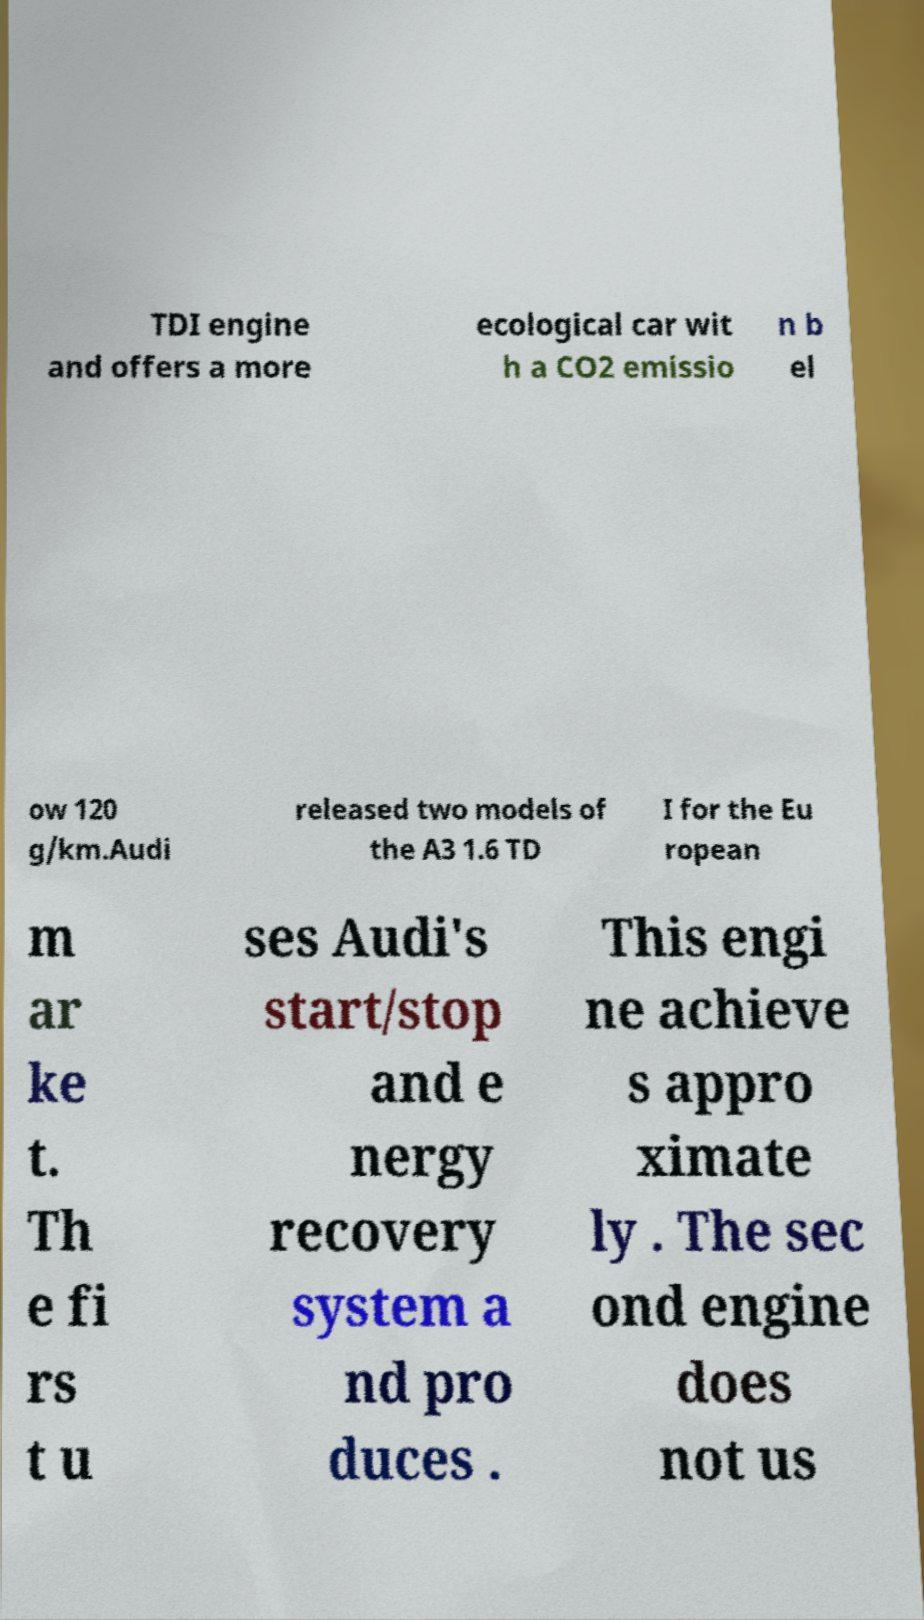Please identify and transcribe the text found in this image. TDI engine and offers a more ecological car wit h a CO2 emissio n b el ow 120 g/km.Audi released two models of the A3 1.6 TD I for the Eu ropean m ar ke t. Th e fi rs t u ses Audi's start/stop and e nergy recovery system a nd pro duces . This engi ne achieve s appro ximate ly . The sec ond engine does not us 